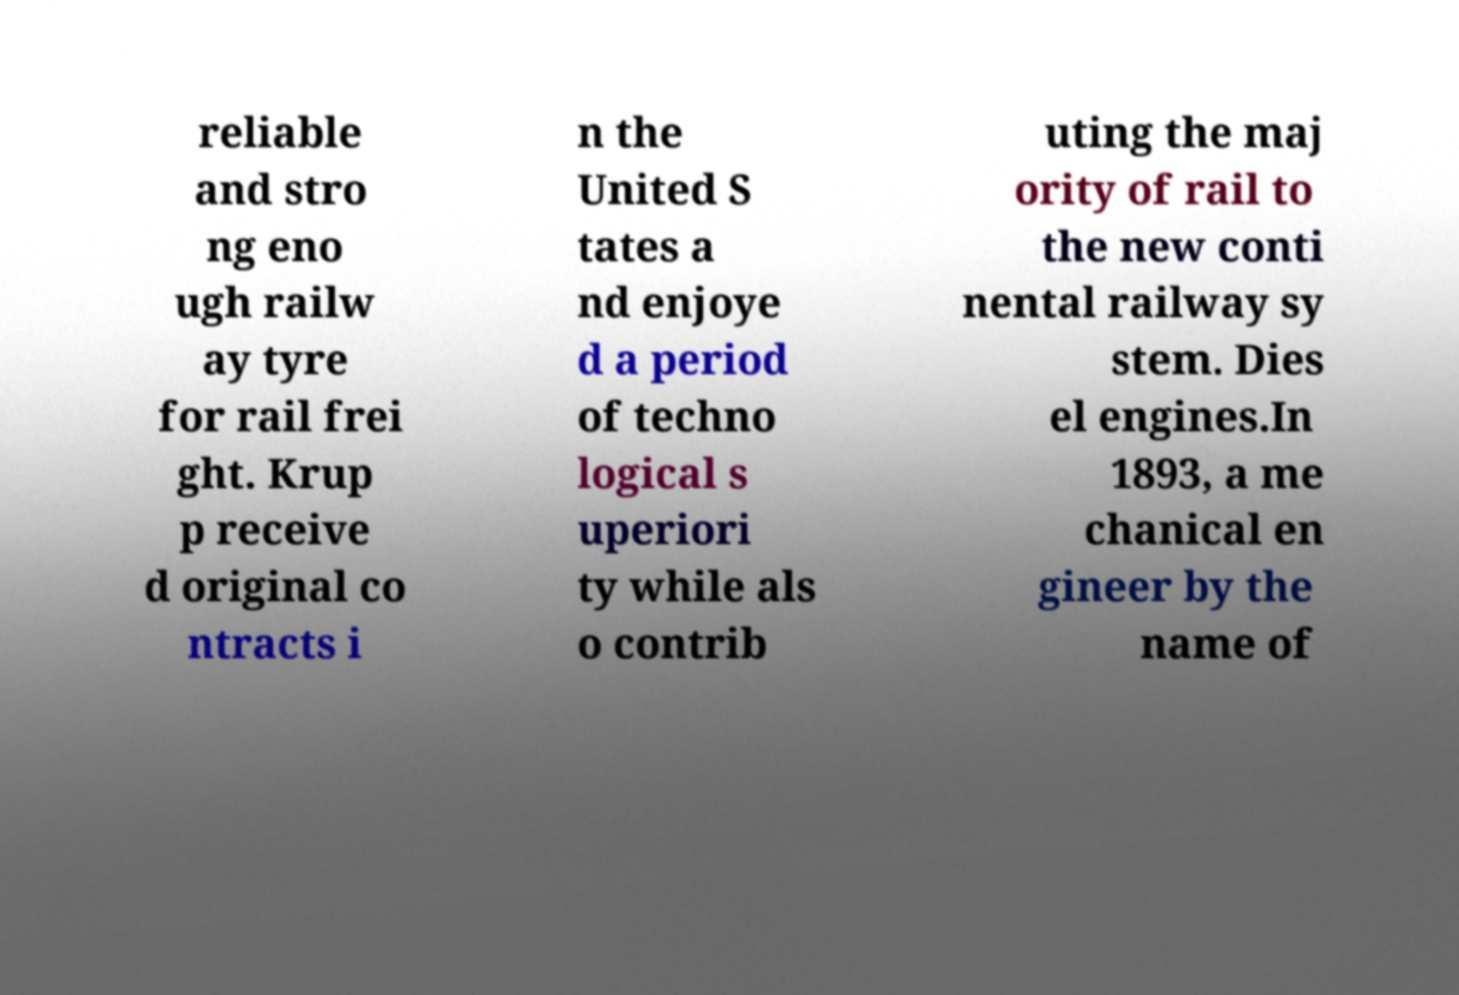Could you extract and type out the text from this image? reliable and stro ng eno ugh railw ay tyre for rail frei ght. Krup p receive d original co ntracts i n the United S tates a nd enjoye d a period of techno logical s uperiori ty while als o contrib uting the maj ority of rail to the new conti nental railway sy stem. Dies el engines.In 1893, a me chanical en gineer by the name of 